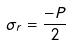<formula> <loc_0><loc_0><loc_500><loc_500>\sigma _ { r } = \frac { - P } { 2 }</formula> 